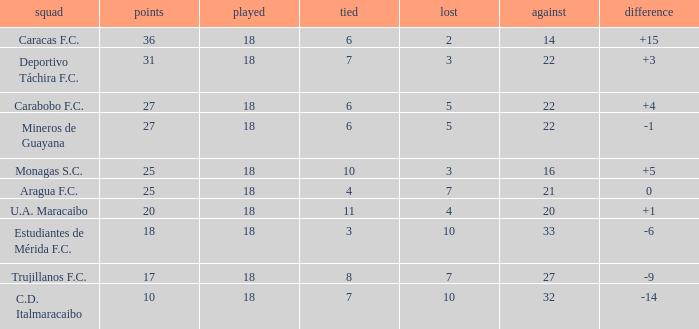What is the sum of the points of all teams that had against scores less than 14? None. 